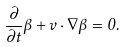Convert formula to latex. <formula><loc_0><loc_0><loc_500><loc_500>\frac { \partial } { \partial t } \beta + v \cdot \nabla \beta = 0 .</formula> 